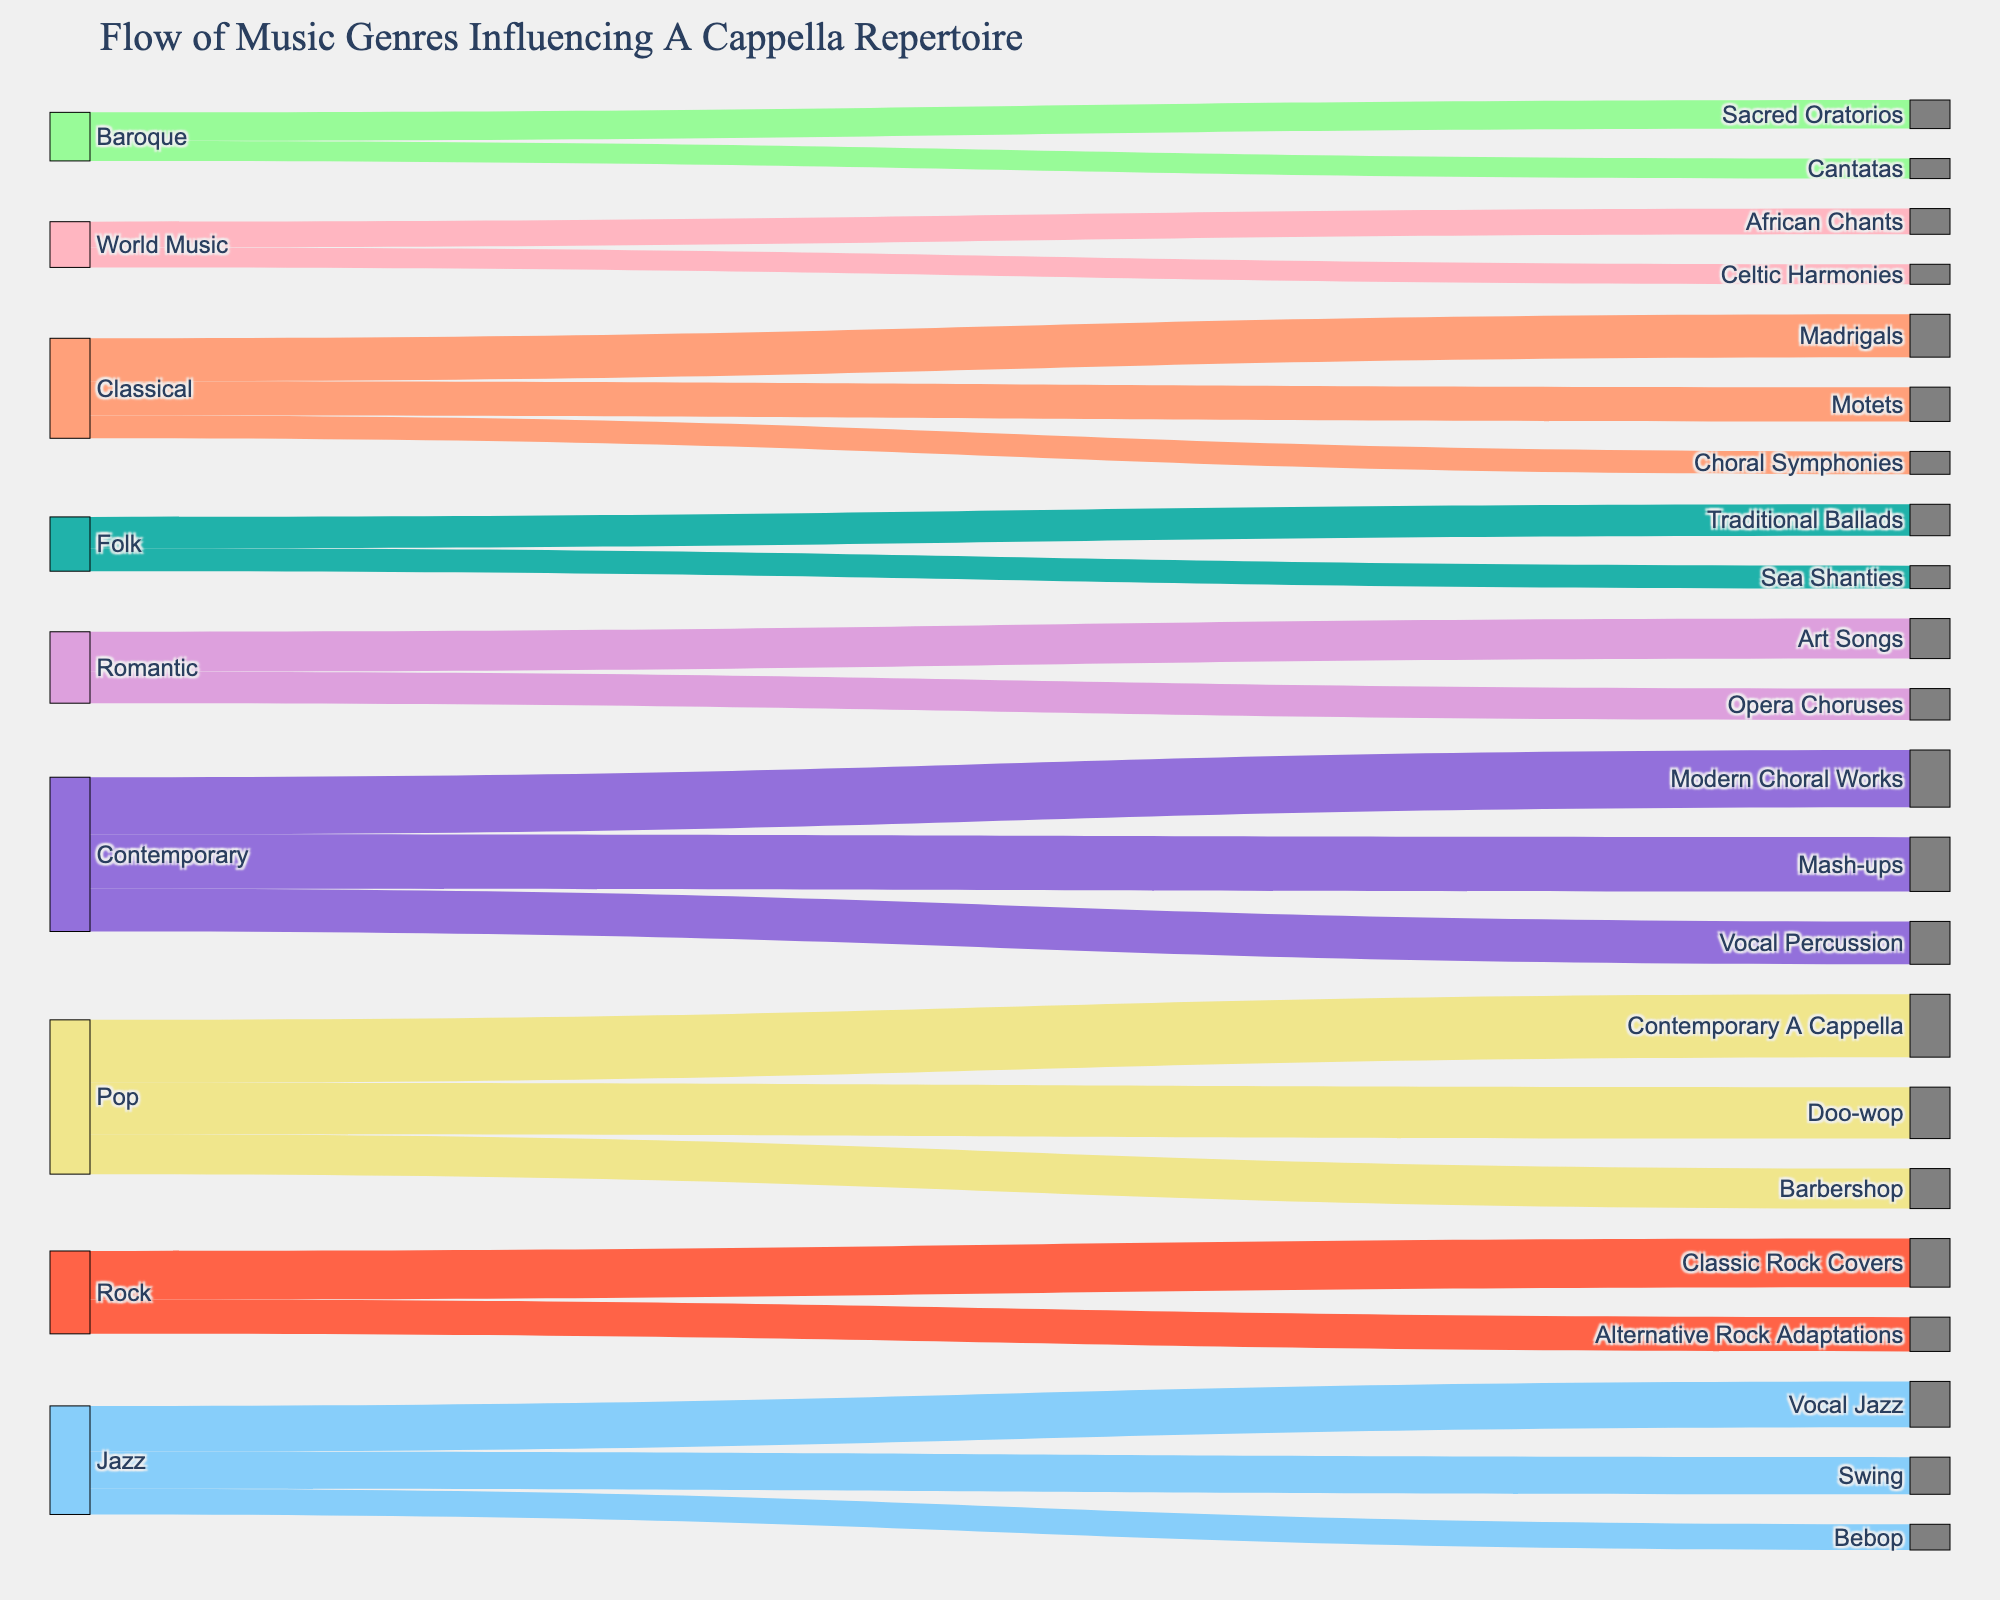What is the title of the diagram? The title of the diagram is typically found at the top and serves to summarize the overall content of the chart. Here, it reads "Flow of Music Genres Influencing A Cappella Repertoire."
Answer: Flow of Music Genres Influencing A Cappella Repertoire Which genre has the highest influence on the a cappella group's repertoire and what is its total contribution? To find the genre with the highest total influence, sum all the values associated with each genre. Pop has contributions of 18, 14, and 22, summing up to 54.
Answer: Pop How many different music genres are influencing the a cappella group's repertoire? Count the unique genres listed as sources in the data table. The genres are Classical, Baroque, Romantic, Jazz, Pop, Rock, Folk, World Music, and Contemporary.
Answer: 9 What classical music styles are influencing the repertoire, and what is their combined influence? Refer to the connections stemming from Classical. The styles are Madrigals (15), Motets (12), and Choral Symphonies (8). The combined influence is 15 + 12 + 8.
Answer: 35 Which genre has the lowest influence on the a cappella group's repertoire? Sum all the contributions from each genre, and compare; World Music has contributions of 9 and 7, totaling 16, which is the lowest.
Answer: World Music How many different styles are influenced by Jazz? Identify the number of target links starting from Jazz. There are three styles: Swing, Bebop, and Vocal Jazz.
Answer: 3 Which two genres combined contribute the most to the repertoire? Sum the contributions of each pair of genres and compare sums. Pop (54) + Contemporary (54) is the highest contribution.
Answer: Pop and Contemporary What is the difference in influence between Rock and Folk genres? Sum the influences for each genre: Rock (17 + 12 = 29) and Folk (11 + 8 = 19). Then find the difference: 29 - 19.
Answer: 10 How does the influence of Modern Choral Works compare to Vocal Percussion in the Contemporary genre? Check the values for Modern Choral Works (20) and Vocal Percussion (15) under Contemporary; compare these values. Modern Choral Works has a higher influence.
Answer: Modern Choral Works is higher Which music genre has the most diverse range of influenced styles, i.e., the most different targets? Count the different target styles each genre influences. Pop influences the most different styles with three targets: Doo-wop, Barbershop, and Contemporary A Cappella.
Answer: Pop 